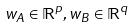Convert formula to latex. <formula><loc_0><loc_0><loc_500><loc_500>w _ { A } \in \mathbb { R } ^ { p } , w _ { B } \in \mathbb { R } ^ { q }</formula> 